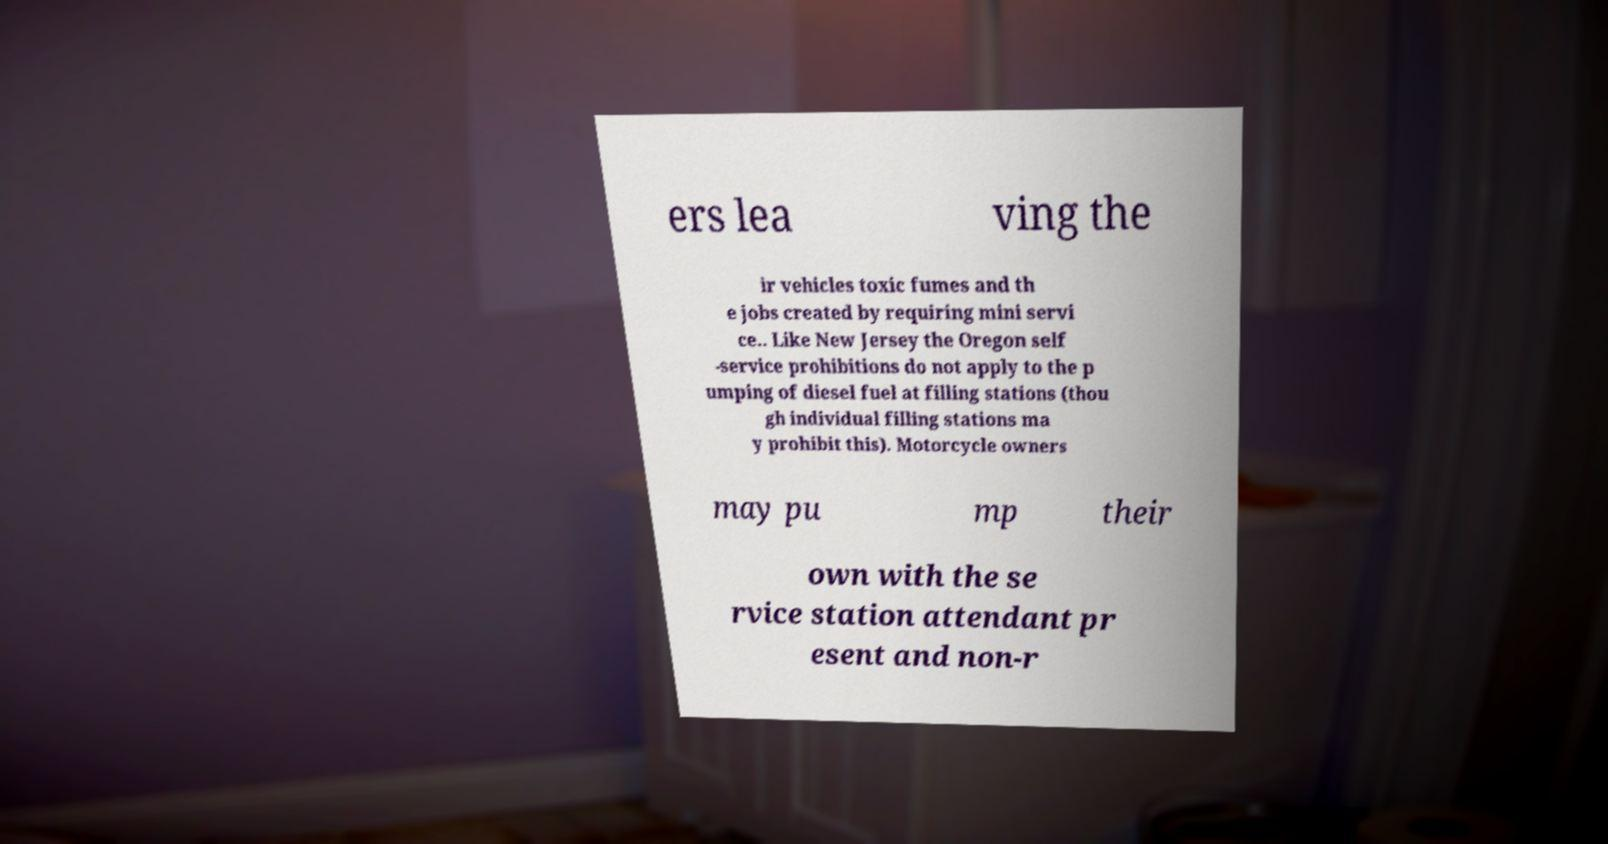Could you assist in decoding the text presented in this image and type it out clearly? ers lea ving the ir vehicles toxic fumes and th e jobs created by requiring mini servi ce.. Like New Jersey the Oregon self -service prohibitions do not apply to the p umping of diesel fuel at filling stations (thou gh individual filling stations ma y prohibit this). Motorcycle owners may pu mp their own with the se rvice station attendant pr esent and non-r 